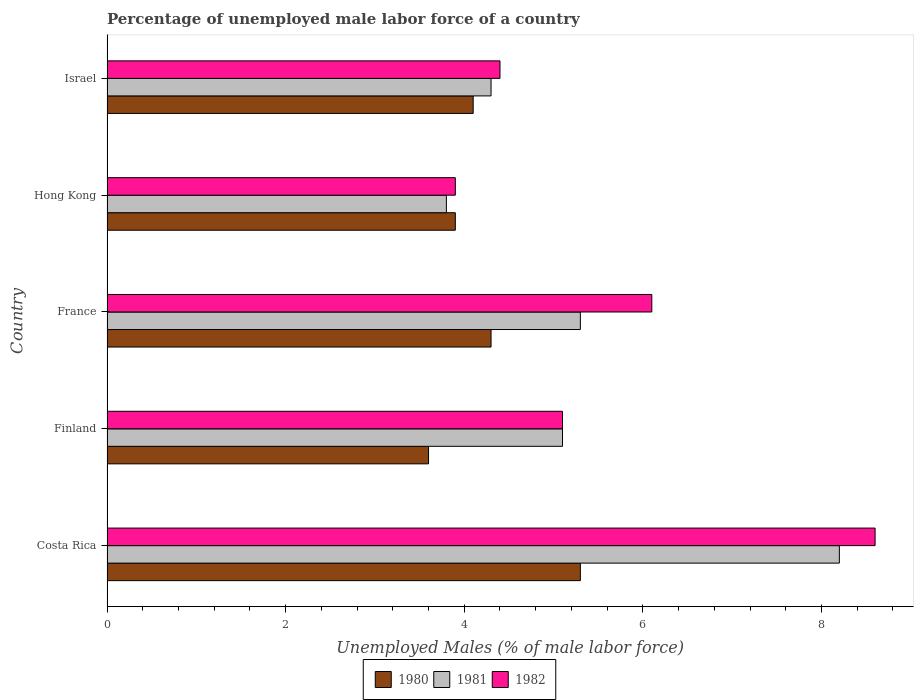Are the number of bars per tick equal to the number of legend labels?
Offer a very short reply. Yes. Are the number of bars on each tick of the Y-axis equal?
Your answer should be very brief. Yes. How many bars are there on the 1st tick from the top?
Keep it short and to the point. 3. What is the label of the 3rd group of bars from the top?
Ensure brevity in your answer.  France. In how many cases, is the number of bars for a given country not equal to the number of legend labels?
Offer a terse response. 0. What is the percentage of unemployed male labor force in 1980 in Costa Rica?
Keep it short and to the point. 5.3. Across all countries, what is the maximum percentage of unemployed male labor force in 1982?
Your answer should be very brief. 8.6. Across all countries, what is the minimum percentage of unemployed male labor force in 1982?
Provide a short and direct response. 3.9. In which country was the percentage of unemployed male labor force in 1981 minimum?
Your answer should be very brief. Hong Kong. What is the total percentage of unemployed male labor force in 1982 in the graph?
Ensure brevity in your answer.  28.1. What is the difference between the percentage of unemployed male labor force in 1980 in Costa Rica and that in Israel?
Offer a very short reply. 1.2. What is the difference between the percentage of unemployed male labor force in 1982 in Hong Kong and the percentage of unemployed male labor force in 1981 in Costa Rica?
Your response must be concise. -4.3. What is the average percentage of unemployed male labor force in 1981 per country?
Your answer should be very brief. 5.34. What is the difference between the percentage of unemployed male labor force in 1980 and percentage of unemployed male labor force in 1982 in France?
Your response must be concise. -1.8. What is the ratio of the percentage of unemployed male labor force in 1981 in Finland to that in France?
Offer a terse response. 0.96. Is the percentage of unemployed male labor force in 1982 in Finland less than that in France?
Your answer should be very brief. Yes. What is the difference between the highest and the second highest percentage of unemployed male labor force in 1982?
Keep it short and to the point. 2.5. What is the difference between the highest and the lowest percentage of unemployed male labor force in 1982?
Offer a terse response. 4.7. Is the sum of the percentage of unemployed male labor force in 1980 in Costa Rica and Israel greater than the maximum percentage of unemployed male labor force in 1981 across all countries?
Your response must be concise. Yes. What does the 2nd bar from the top in Israel represents?
Provide a succinct answer. 1981. What does the 2nd bar from the bottom in Hong Kong represents?
Give a very brief answer. 1981. How many bars are there?
Ensure brevity in your answer.  15. Are all the bars in the graph horizontal?
Provide a short and direct response. Yes. How many countries are there in the graph?
Give a very brief answer. 5. What is the difference between two consecutive major ticks on the X-axis?
Provide a succinct answer. 2. Does the graph contain grids?
Ensure brevity in your answer.  No. How many legend labels are there?
Your answer should be compact. 3. How are the legend labels stacked?
Your answer should be very brief. Horizontal. What is the title of the graph?
Keep it short and to the point. Percentage of unemployed male labor force of a country. Does "2009" appear as one of the legend labels in the graph?
Your answer should be compact. No. What is the label or title of the X-axis?
Offer a very short reply. Unemployed Males (% of male labor force). What is the label or title of the Y-axis?
Make the answer very short. Country. What is the Unemployed Males (% of male labor force) of 1980 in Costa Rica?
Provide a short and direct response. 5.3. What is the Unemployed Males (% of male labor force) of 1981 in Costa Rica?
Offer a terse response. 8.2. What is the Unemployed Males (% of male labor force) of 1982 in Costa Rica?
Your answer should be very brief. 8.6. What is the Unemployed Males (% of male labor force) in 1980 in Finland?
Your answer should be compact. 3.6. What is the Unemployed Males (% of male labor force) of 1981 in Finland?
Your answer should be very brief. 5.1. What is the Unemployed Males (% of male labor force) in 1982 in Finland?
Ensure brevity in your answer.  5.1. What is the Unemployed Males (% of male labor force) in 1980 in France?
Provide a succinct answer. 4.3. What is the Unemployed Males (% of male labor force) of 1981 in France?
Your answer should be compact. 5.3. What is the Unemployed Males (% of male labor force) in 1982 in France?
Your answer should be compact. 6.1. What is the Unemployed Males (% of male labor force) in 1980 in Hong Kong?
Offer a terse response. 3.9. What is the Unemployed Males (% of male labor force) of 1981 in Hong Kong?
Provide a short and direct response. 3.8. What is the Unemployed Males (% of male labor force) in 1982 in Hong Kong?
Give a very brief answer. 3.9. What is the Unemployed Males (% of male labor force) in 1980 in Israel?
Your response must be concise. 4.1. What is the Unemployed Males (% of male labor force) of 1981 in Israel?
Give a very brief answer. 4.3. What is the Unemployed Males (% of male labor force) in 1982 in Israel?
Give a very brief answer. 4.4. Across all countries, what is the maximum Unemployed Males (% of male labor force) of 1980?
Provide a short and direct response. 5.3. Across all countries, what is the maximum Unemployed Males (% of male labor force) of 1981?
Ensure brevity in your answer.  8.2. Across all countries, what is the maximum Unemployed Males (% of male labor force) of 1982?
Provide a short and direct response. 8.6. Across all countries, what is the minimum Unemployed Males (% of male labor force) in 1980?
Ensure brevity in your answer.  3.6. Across all countries, what is the minimum Unemployed Males (% of male labor force) in 1981?
Your response must be concise. 3.8. Across all countries, what is the minimum Unemployed Males (% of male labor force) of 1982?
Provide a short and direct response. 3.9. What is the total Unemployed Males (% of male labor force) in 1980 in the graph?
Ensure brevity in your answer.  21.2. What is the total Unemployed Males (% of male labor force) of 1981 in the graph?
Keep it short and to the point. 26.7. What is the total Unemployed Males (% of male labor force) of 1982 in the graph?
Your response must be concise. 28.1. What is the difference between the Unemployed Males (% of male labor force) of 1980 in Costa Rica and that in Finland?
Keep it short and to the point. 1.7. What is the difference between the Unemployed Males (% of male labor force) of 1981 in Costa Rica and that in Finland?
Offer a very short reply. 3.1. What is the difference between the Unemployed Males (% of male labor force) in 1980 in Costa Rica and that in France?
Make the answer very short. 1. What is the difference between the Unemployed Males (% of male labor force) in 1980 in Costa Rica and that in Hong Kong?
Offer a very short reply. 1.4. What is the difference between the Unemployed Males (% of male labor force) of 1982 in Costa Rica and that in Hong Kong?
Make the answer very short. 4.7. What is the difference between the Unemployed Males (% of male labor force) in 1981 in Costa Rica and that in Israel?
Provide a short and direct response. 3.9. What is the difference between the Unemployed Males (% of male labor force) in 1980 in Finland and that in France?
Make the answer very short. -0.7. What is the difference between the Unemployed Males (% of male labor force) in 1981 in Finland and that in France?
Your response must be concise. -0.2. What is the difference between the Unemployed Males (% of male labor force) in 1982 in Finland and that in Hong Kong?
Offer a very short reply. 1.2. What is the difference between the Unemployed Males (% of male labor force) of 1980 in Finland and that in Israel?
Your response must be concise. -0.5. What is the difference between the Unemployed Males (% of male labor force) of 1981 in Finland and that in Israel?
Ensure brevity in your answer.  0.8. What is the difference between the Unemployed Males (% of male labor force) in 1982 in Finland and that in Israel?
Your response must be concise. 0.7. What is the difference between the Unemployed Males (% of male labor force) of 1980 in France and that in Hong Kong?
Provide a succinct answer. 0.4. What is the difference between the Unemployed Males (% of male labor force) in 1981 in France and that in Hong Kong?
Offer a very short reply. 1.5. What is the difference between the Unemployed Males (% of male labor force) in 1982 in France and that in Hong Kong?
Provide a succinct answer. 2.2. What is the difference between the Unemployed Males (% of male labor force) of 1981 in France and that in Israel?
Give a very brief answer. 1. What is the difference between the Unemployed Males (% of male labor force) in 1982 in France and that in Israel?
Provide a short and direct response. 1.7. What is the difference between the Unemployed Males (% of male labor force) in 1981 in Hong Kong and that in Israel?
Offer a very short reply. -0.5. What is the difference between the Unemployed Males (% of male labor force) of 1980 in Costa Rica and the Unemployed Males (% of male labor force) of 1981 in Hong Kong?
Offer a terse response. 1.5. What is the difference between the Unemployed Males (% of male labor force) in 1980 in Costa Rica and the Unemployed Males (% of male labor force) in 1982 in Hong Kong?
Your answer should be compact. 1.4. What is the difference between the Unemployed Males (% of male labor force) in 1980 in Costa Rica and the Unemployed Males (% of male labor force) in 1982 in Israel?
Your answer should be compact. 0.9. What is the difference between the Unemployed Males (% of male labor force) in 1980 in Finland and the Unemployed Males (% of male labor force) in 1982 in France?
Provide a succinct answer. -2.5. What is the difference between the Unemployed Males (% of male labor force) in 1981 in Finland and the Unemployed Males (% of male labor force) in 1982 in France?
Keep it short and to the point. -1. What is the difference between the Unemployed Males (% of male labor force) in 1981 in Finland and the Unemployed Males (% of male labor force) in 1982 in Hong Kong?
Give a very brief answer. 1.2. What is the difference between the Unemployed Males (% of male labor force) of 1980 in France and the Unemployed Males (% of male labor force) of 1981 in Hong Kong?
Offer a very short reply. 0.5. What is the difference between the Unemployed Males (% of male labor force) in 1980 in France and the Unemployed Males (% of male labor force) in 1982 in Hong Kong?
Your answer should be very brief. 0.4. What is the difference between the Unemployed Males (% of male labor force) of 1980 in France and the Unemployed Males (% of male labor force) of 1981 in Israel?
Your response must be concise. 0. What is the difference between the Unemployed Males (% of male labor force) in 1981 in France and the Unemployed Males (% of male labor force) in 1982 in Israel?
Provide a succinct answer. 0.9. What is the difference between the Unemployed Males (% of male labor force) of 1980 in Hong Kong and the Unemployed Males (% of male labor force) of 1982 in Israel?
Your answer should be compact. -0.5. What is the average Unemployed Males (% of male labor force) of 1980 per country?
Offer a very short reply. 4.24. What is the average Unemployed Males (% of male labor force) in 1981 per country?
Provide a succinct answer. 5.34. What is the average Unemployed Males (% of male labor force) of 1982 per country?
Make the answer very short. 5.62. What is the difference between the Unemployed Males (% of male labor force) in 1980 and Unemployed Males (% of male labor force) in 1982 in Costa Rica?
Ensure brevity in your answer.  -3.3. What is the difference between the Unemployed Males (% of male labor force) of 1981 and Unemployed Males (% of male labor force) of 1982 in Costa Rica?
Your answer should be compact. -0.4. What is the difference between the Unemployed Males (% of male labor force) in 1980 and Unemployed Males (% of male labor force) in 1981 in Finland?
Your answer should be very brief. -1.5. What is the difference between the Unemployed Males (% of male labor force) of 1980 and Unemployed Males (% of male labor force) of 1982 in France?
Your response must be concise. -1.8. What is the difference between the Unemployed Males (% of male labor force) of 1981 and Unemployed Males (% of male labor force) of 1982 in France?
Your response must be concise. -0.8. What is the difference between the Unemployed Males (% of male labor force) in 1980 and Unemployed Males (% of male labor force) in 1981 in Israel?
Your answer should be compact. -0.2. What is the difference between the Unemployed Males (% of male labor force) in 1981 and Unemployed Males (% of male labor force) in 1982 in Israel?
Your answer should be compact. -0.1. What is the ratio of the Unemployed Males (% of male labor force) in 1980 in Costa Rica to that in Finland?
Offer a terse response. 1.47. What is the ratio of the Unemployed Males (% of male labor force) of 1981 in Costa Rica to that in Finland?
Your answer should be compact. 1.61. What is the ratio of the Unemployed Males (% of male labor force) of 1982 in Costa Rica to that in Finland?
Your response must be concise. 1.69. What is the ratio of the Unemployed Males (% of male labor force) in 1980 in Costa Rica to that in France?
Offer a terse response. 1.23. What is the ratio of the Unemployed Males (% of male labor force) of 1981 in Costa Rica to that in France?
Your answer should be very brief. 1.55. What is the ratio of the Unemployed Males (% of male labor force) in 1982 in Costa Rica to that in France?
Provide a short and direct response. 1.41. What is the ratio of the Unemployed Males (% of male labor force) of 1980 in Costa Rica to that in Hong Kong?
Provide a short and direct response. 1.36. What is the ratio of the Unemployed Males (% of male labor force) in 1981 in Costa Rica to that in Hong Kong?
Provide a short and direct response. 2.16. What is the ratio of the Unemployed Males (% of male labor force) in 1982 in Costa Rica to that in Hong Kong?
Give a very brief answer. 2.21. What is the ratio of the Unemployed Males (% of male labor force) in 1980 in Costa Rica to that in Israel?
Your answer should be very brief. 1.29. What is the ratio of the Unemployed Males (% of male labor force) of 1981 in Costa Rica to that in Israel?
Give a very brief answer. 1.91. What is the ratio of the Unemployed Males (% of male labor force) of 1982 in Costa Rica to that in Israel?
Ensure brevity in your answer.  1.95. What is the ratio of the Unemployed Males (% of male labor force) in 1980 in Finland to that in France?
Make the answer very short. 0.84. What is the ratio of the Unemployed Males (% of male labor force) of 1981 in Finland to that in France?
Provide a succinct answer. 0.96. What is the ratio of the Unemployed Males (% of male labor force) of 1982 in Finland to that in France?
Provide a short and direct response. 0.84. What is the ratio of the Unemployed Males (% of male labor force) of 1980 in Finland to that in Hong Kong?
Keep it short and to the point. 0.92. What is the ratio of the Unemployed Males (% of male labor force) in 1981 in Finland to that in Hong Kong?
Give a very brief answer. 1.34. What is the ratio of the Unemployed Males (% of male labor force) in 1982 in Finland to that in Hong Kong?
Provide a succinct answer. 1.31. What is the ratio of the Unemployed Males (% of male labor force) in 1980 in Finland to that in Israel?
Ensure brevity in your answer.  0.88. What is the ratio of the Unemployed Males (% of male labor force) in 1981 in Finland to that in Israel?
Offer a terse response. 1.19. What is the ratio of the Unemployed Males (% of male labor force) in 1982 in Finland to that in Israel?
Make the answer very short. 1.16. What is the ratio of the Unemployed Males (% of male labor force) in 1980 in France to that in Hong Kong?
Make the answer very short. 1.1. What is the ratio of the Unemployed Males (% of male labor force) in 1981 in France to that in Hong Kong?
Provide a succinct answer. 1.39. What is the ratio of the Unemployed Males (% of male labor force) in 1982 in France to that in Hong Kong?
Your response must be concise. 1.56. What is the ratio of the Unemployed Males (% of male labor force) in 1980 in France to that in Israel?
Give a very brief answer. 1.05. What is the ratio of the Unemployed Males (% of male labor force) of 1981 in France to that in Israel?
Make the answer very short. 1.23. What is the ratio of the Unemployed Males (% of male labor force) of 1982 in France to that in Israel?
Your answer should be very brief. 1.39. What is the ratio of the Unemployed Males (% of male labor force) in 1980 in Hong Kong to that in Israel?
Ensure brevity in your answer.  0.95. What is the ratio of the Unemployed Males (% of male labor force) in 1981 in Hong Kong to that in Israel?
Give a very brief answer. 0.88. What is the ratio of the Unemployed Males (% of male labor force) of 1982 in Hong Kong to that in Israel?
Keep it short and to the point. 0.89. What is the difference between the highest and the second highest Unemployed Males (% of male labor force) in 1982?
Your answer should be very brief. 2.5. What is the difference between the highest and the lowest Unemployed Males (% of male labor force) of 1980?
Offer a very short reply. 1.7. 